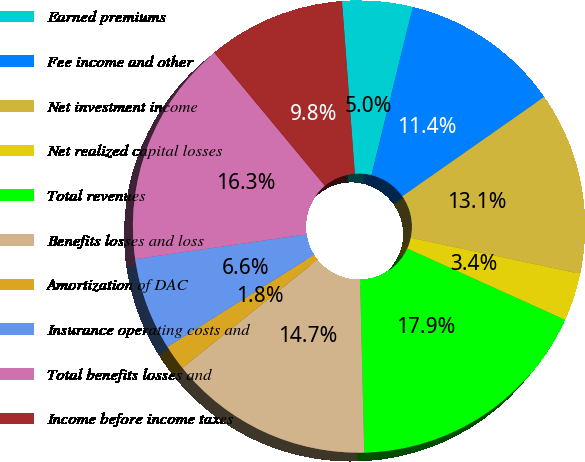Convert chart. <chart><loc_0><loc_0><loc_500><loc_500><pie_chart><fcel>Earned premiums<fcel>Fee income and other<fcel>Net investment income<fcel>Net realized capital losses<fcel>Total revenues<fcel>Benefits losses and loss<fcel>Amortization of DAC<fcel>Insurance operating costs and<fcel>Total benefits losses and<fcel>Income before income taxes<nl><fcel>5.02%<fcel>11.44%<fcel>13.05%<fcel>3.42%<fcel>17.86%<fcel>14.65%<fcel>1.81%<fcel>6.63%<fcel>16.26%<fcel>9.84%<nl></chart> 